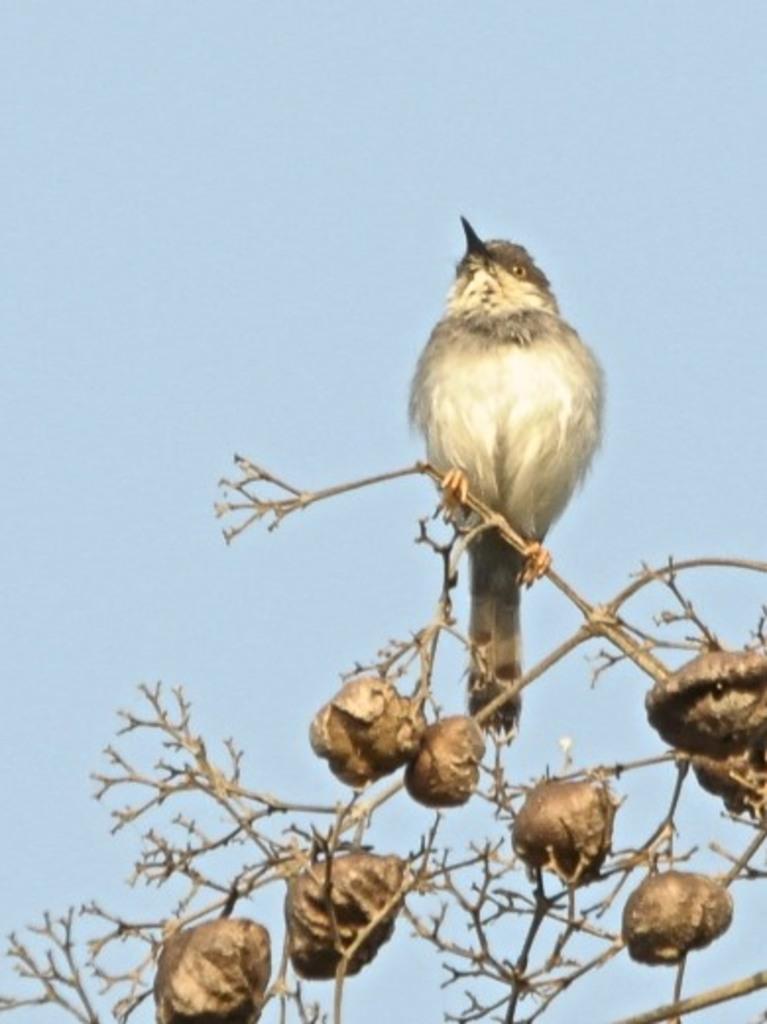Describe this image in one or two sentences. In this image in the front there is a bird standing on the plant and the sky is cloudy. 